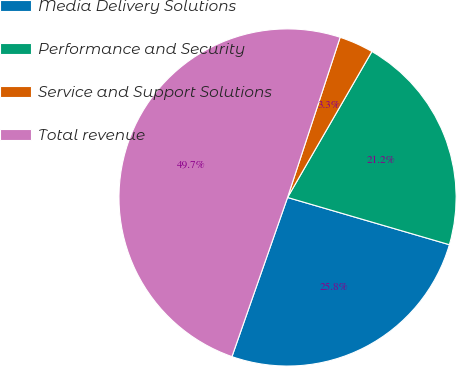<chart> <loc_0><loc_0><loc_500><loc_500><pie_chart><fcel>Media Delivery Solutions<fcel>Performance and Security<fcel>Service and Support Solutions<fcel>Total revenue<nl><fcel>25.83%<fcel>21.18%<fcel>3.29%<fcel>49.7%<nl></chart> 